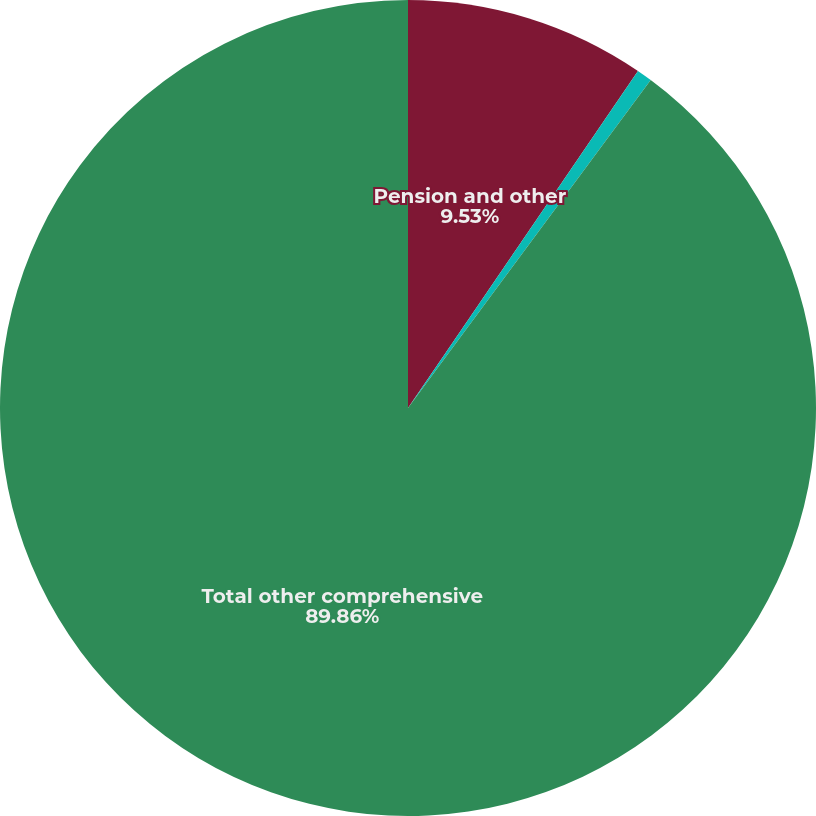Convert chart to OTSL. <chart><loc_0><loc_0><loc_500><loc_500><pie_chart><fcel>Pension and other<fcel>Changes in fair value of cash<fcel>Total other comprehensive<nl><fcel>9.53%<fcel>0.61%<fcel>89.86%<nl></chart> 